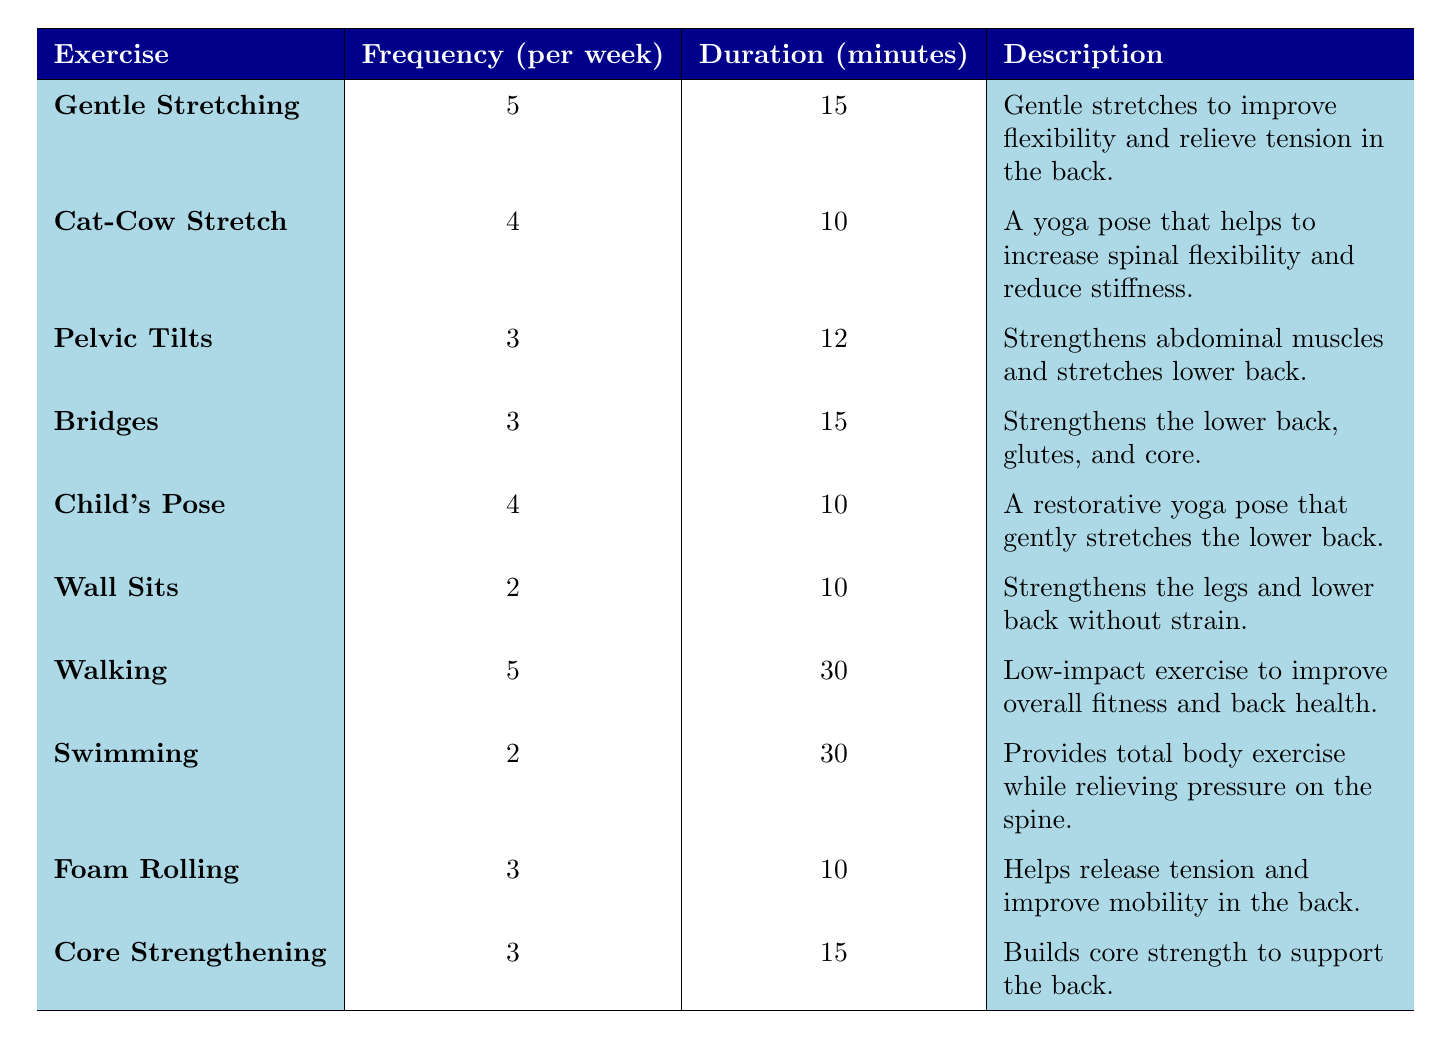What is the frequency of Gentle Stretching per week? The table lists Gentle Stretching with a frequency of 5 times per week.
Answer: 5 How long is each session of the Cat-Cow Stretch? According to the table, each session of the Cat-Cow Stretch lasts for 10 minutes.
Answer: 10 minutes Which exercises are performed 3 times a week? The table shows Pelvic Tilts, Bridges, Foam Rolling, and Core Strengthening are all performed 3 times per week.
Answer: Pelvic Tilts, Bridges, Foam Rolling, Core Strengthening What is the total duration in minutes for a week of Walking? Walking is performed 5 times a week for 30 minutes each session, so the total duration is 5 * 30 = 150 minutes.
Answer: 150 minutes Is the duration of Wall Sits longer than 10 minutes? The table indicates that Wall Sits have a duration of 10 minutes, so the statement is false.
Answer: No What is the average duration of exercises performed 4 times per week? The exercises performed 4 times are Cat-Cow Stretch (10 minutes) and Child's Pose (10 minutes). The sum is 10 + 10 = 20 minutes, divided by 2 gives an average of 10 minutes.
Answer: 10 minutes What is the difference in frequency between Walking and Wall Sits? Walking occurs 5 times per week, and Wall Sits occur 2 times. The difference is 5 - 2 = 3.
Answer: 3 If I do all exercises listed in the table, how many sessions would I complete in a week? Adding the frequency of all exercises gives 5 (Gentle Stretching) + 4 (Cat-Cow Stretch) + 3 (Pelvic Tilts) + 3 (Bridges) + 4 (Child's Pose) + 2 (Wall Sits) + 5 (Walking) + 2 (Swimming) + 3 (Foam Rolling) + 3 (Core Strengthening) = 34 sessions.
Answer: 34 sessions Which exercise has the longest duration per session? Walking has the longest duration at 30 minutes per session.
Answer: Walking Would combining the frequency of Pelvic Tilts and Bridges result in a higher frequency than a single session of Swimming? The combined frequency of Pelvic Tilts (3) and Bridges (3) equals 6, which is more than Swimming's frequency of 2.
Answer: Yes 